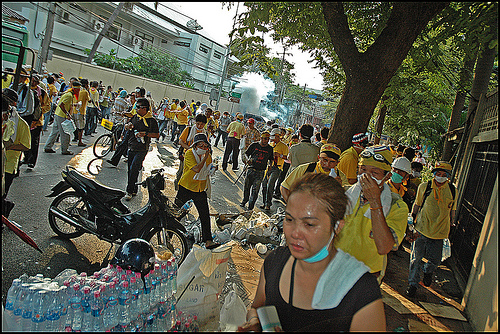<image>
Can you confirm if the woman is to the right of the water bottles? Yes. From this viewpoint, the woman is positioned to the right side relative to the water bottles. Is the bottle on the cycle? No. The bottle is not positioned on the cycle. They may be near each other, but the bottle is not supported by or resting on top of the cycle. 